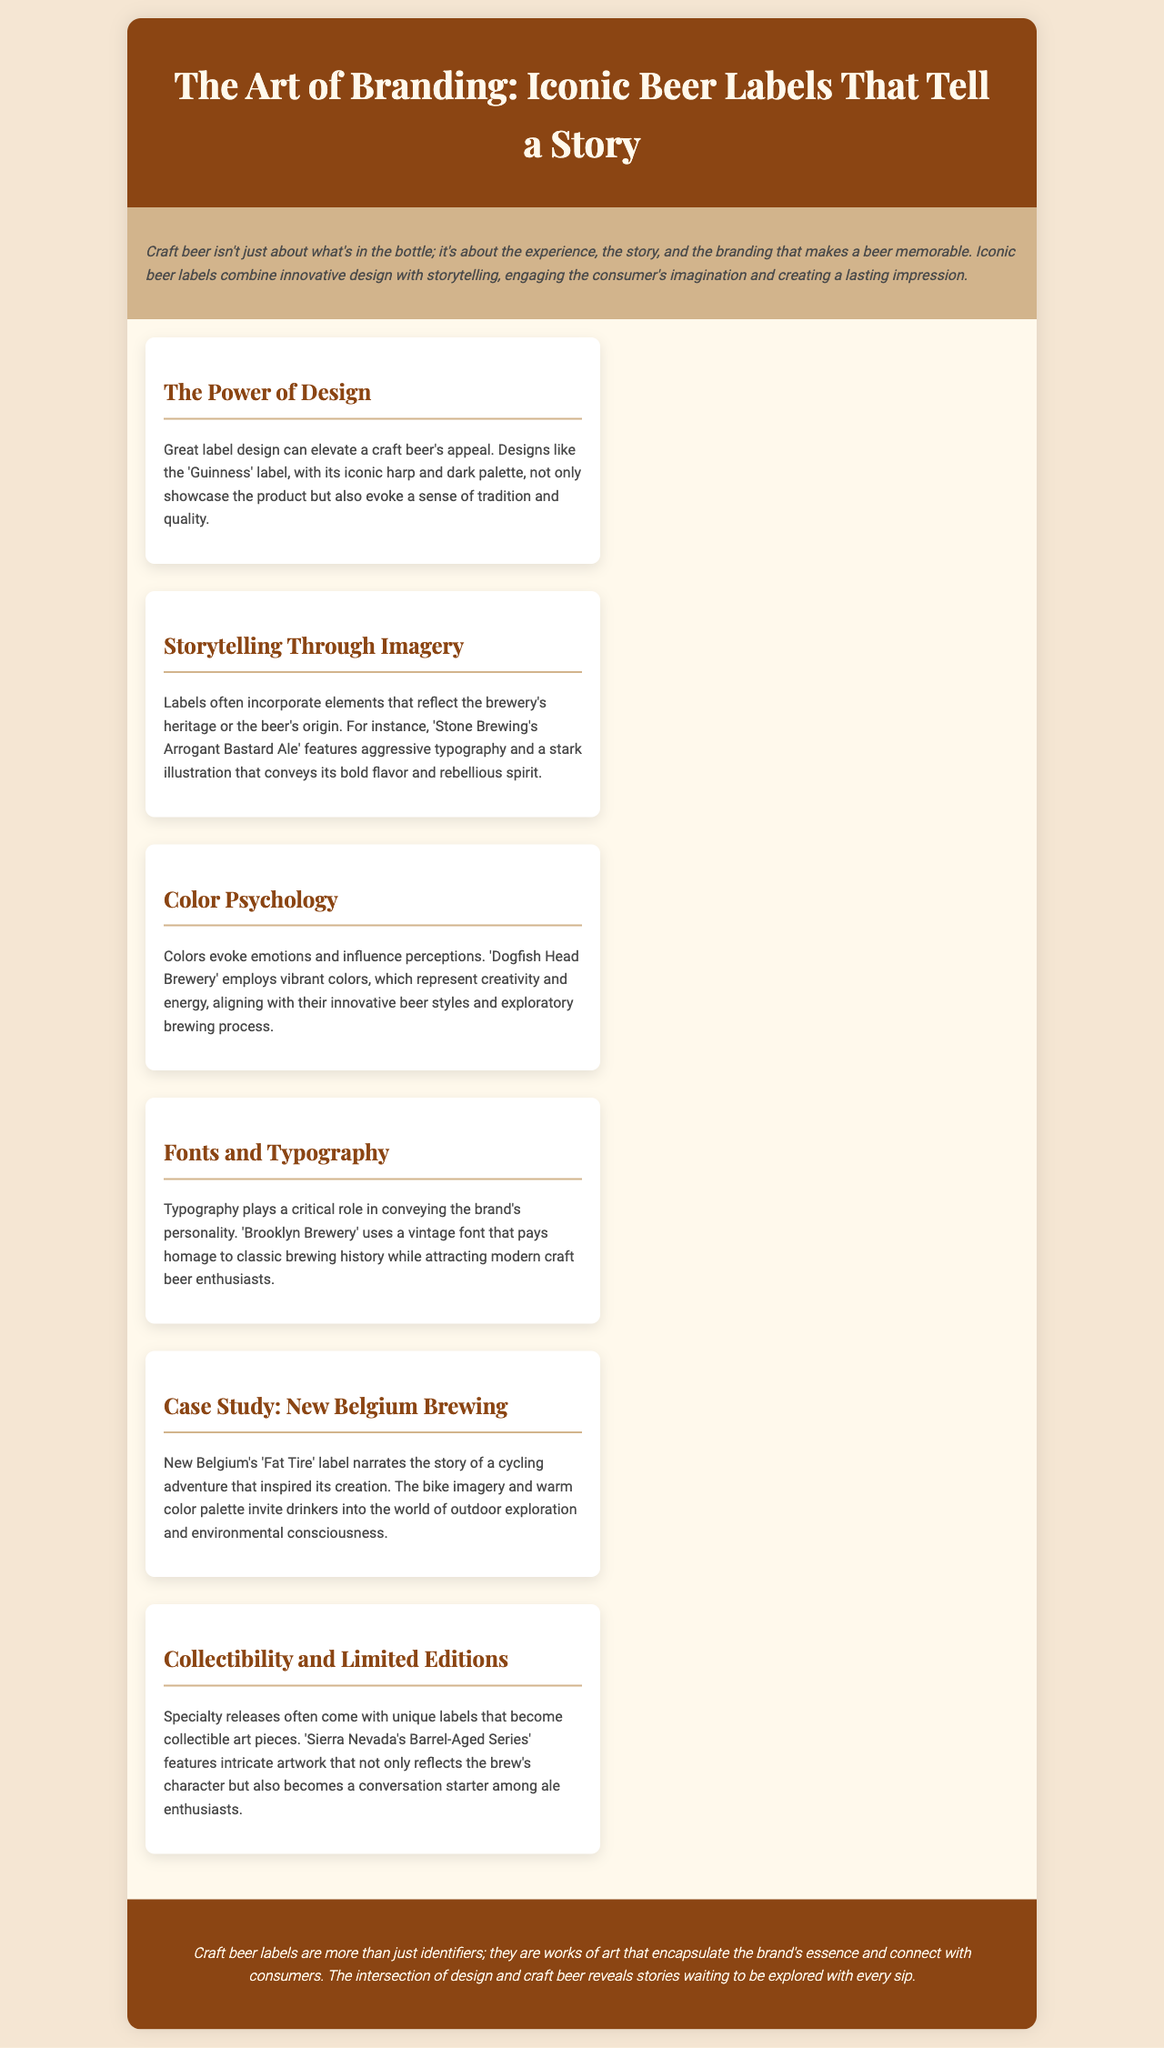What is the title of the brochure? The title of the brochure is presented prominently at the top of the document.
Answer: The Art of Branding: Iconic Beer Labels That Tell a Story What does the introduction emphasize about craft beer? The introduction discusses the significance of branding and storytelling in craft beer beyond the product itself.
Answer: The experience, the story, and the branding Name one iconic beer label mentioned in the document. The document details specific examples of iconic beer labels that are well-known in the craft beer industry.
Answer: Guinness What color palette is associated with New Belgium's Fat Tire label? The summary of the case study about New Belgium Brewing describes the color palette that enhances its storytelling.
Answer: Warm color palette What design element reflects creativity and energy for Dogfish Head Brewery? The document mentions specific colors used by Dogfish Head Brewery in their branding.
Answer: Vibrant colors Which typography is used by Brooklyn Brewery? The section details the style of font used by Brooklyn Brewery that connects to its brand identity.
Answer: Vintage font How do specialty releases affect collectors? The section on collectibility discusses the impact of unique labels on the value and desirability for collectors.
Answer: Become collectible art pieces What is the overall message conveyed in the conclusion? The conclusion summarizes the broader implications of craft beer labels discussed in the brochure.
Answer: Works of art that encapsulate the brand's essence 